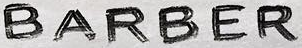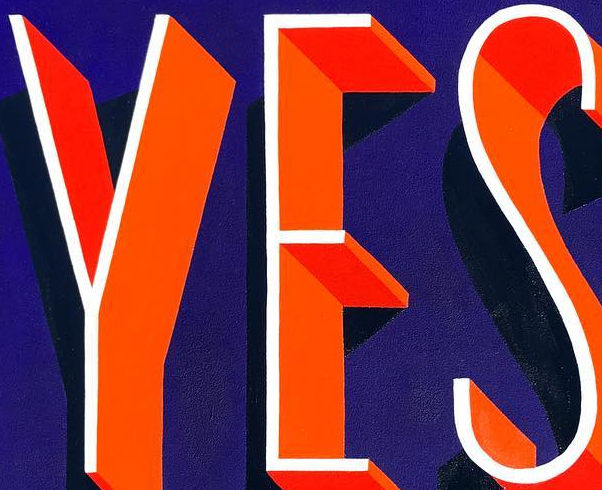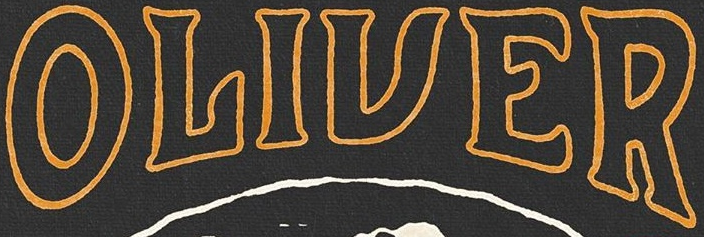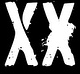Read the text content from these images in order, separated by a semicolon. BARBER; YES; OLIVER; XX 